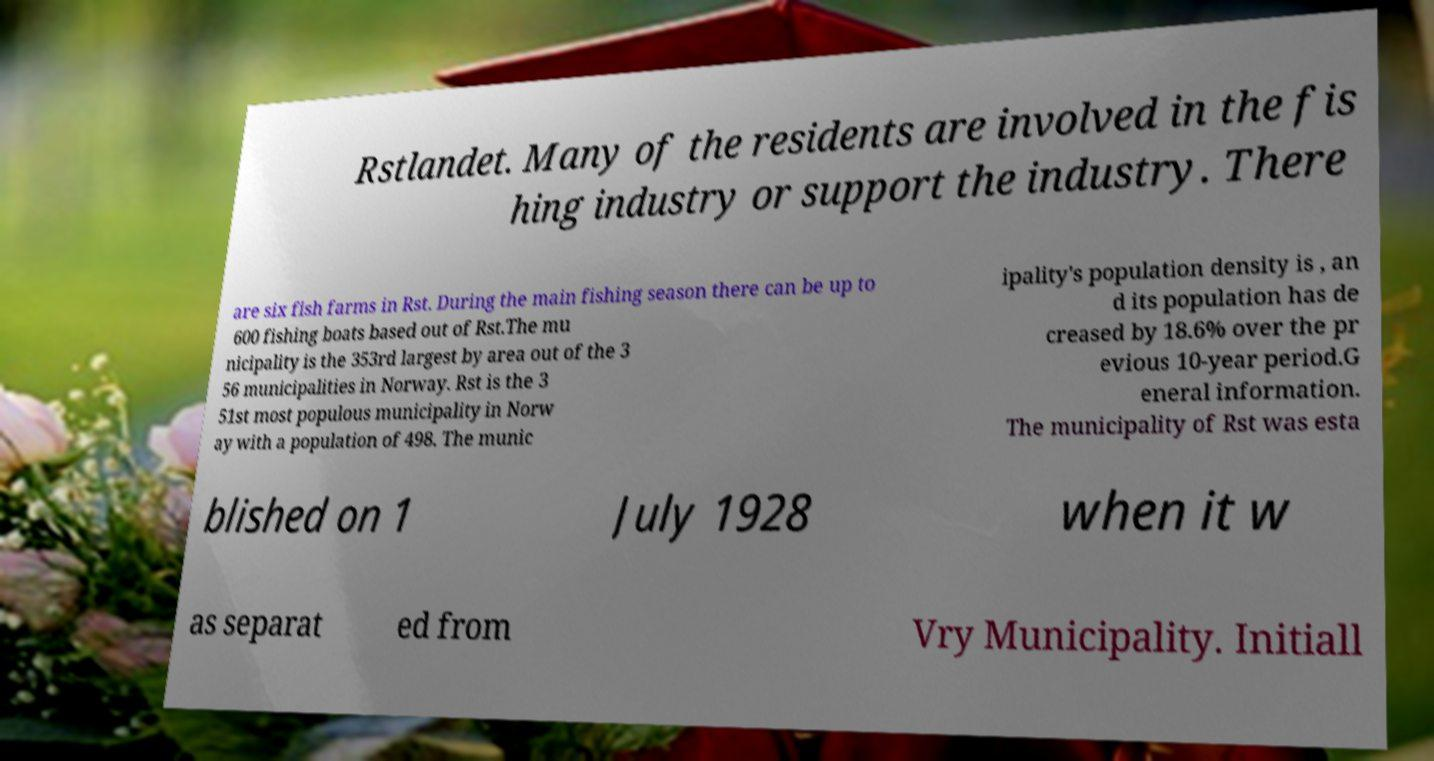I need the written content from this picture converted into text. Can you do that? Rstlandet. Many of the residents are involved in the fis hing industry or support the industry. There are six fish farms in Rst. During the main fishing season there can be up to 600 fishing boats based out of Rst.The mu nicipality is the 353rd largest by area out of the 3 56 municipalities in Norway. Rst is the 3 51st most populous municipality in Norw ay with a population of 498. The munic ipality's population density is , an d its population has de creased by 18.6% over the pr evious 10-year period.G eneral information. The municipality of Rst was esta blished on 1 July 1928 when it w as separat ed from Vry Municipality. Initiall 